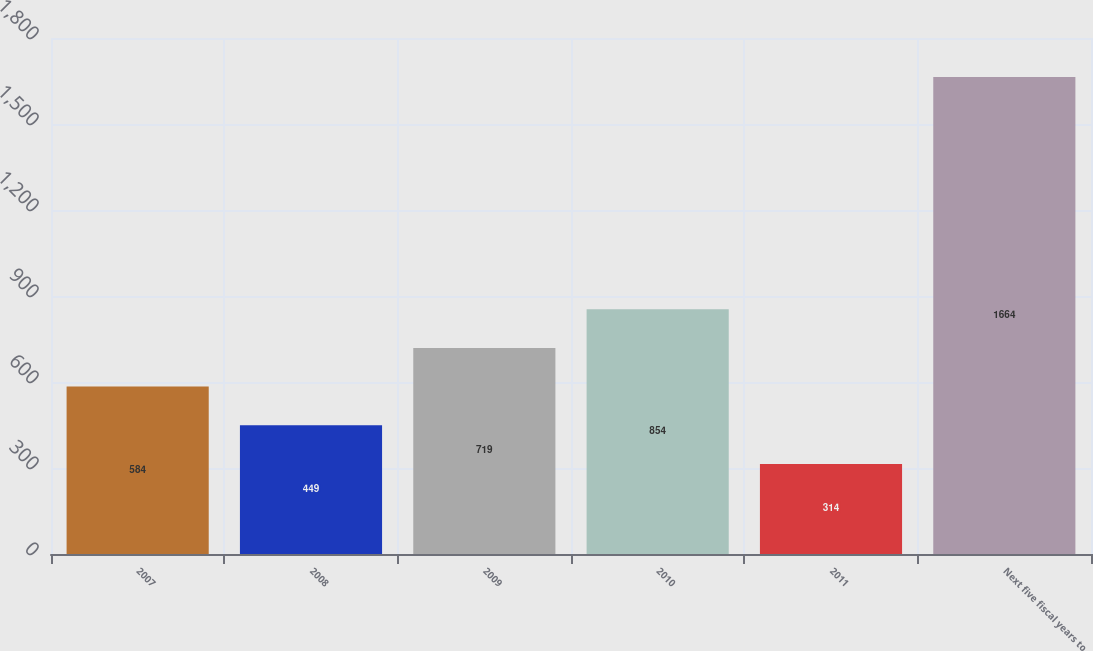Convert chart. <chart><loc_0><loc_0><loc_500><loc_500><bar_chart><fcel>2007<fcel>2008<fcel>2009<fcel>2010<fcel>2011<fcel>Next five fiscal years to<nl><fcel>584<fcel>449<fcel>719<fcel>854<fcel>314<fcel>1664<nl></chart> 